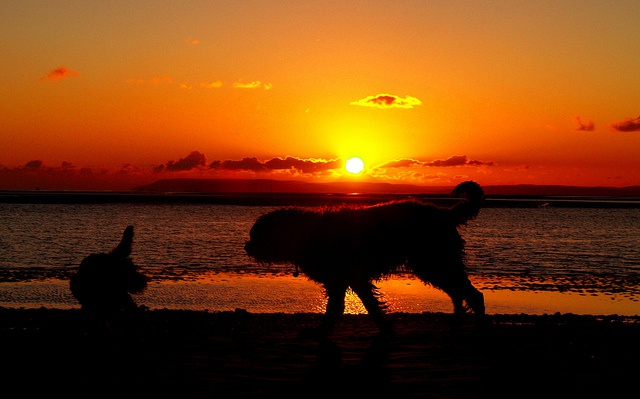Describe the objects in this image and their specific colors. I can see dog in olive, black, maroon, and red tones and dog in maroon, black, and olive tones in this image. 